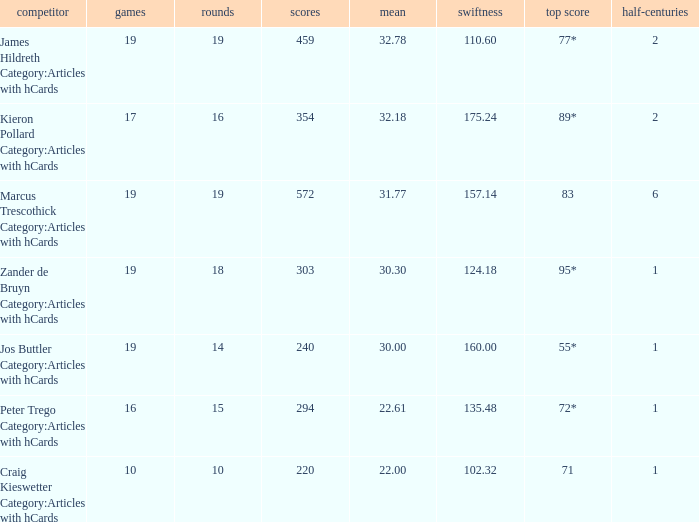What is the strike rate for the player with an average of 32.78? 110.6. 